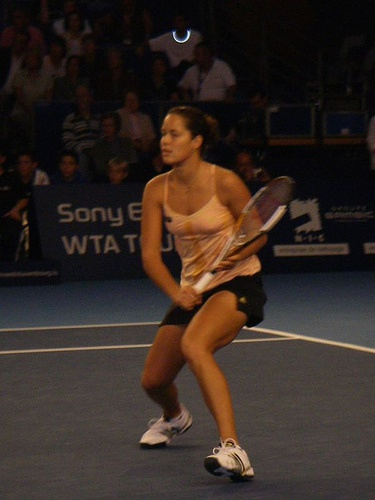Describe the objects in this image and their specific colors. I can see people in black, brown, and maroon tones, tennis racket in black, maroon, and brown tones, people in black and maroon tones, people in black tones, and chair in black tones in this image. 